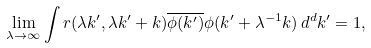<formula> <loc_0><loc_0><loc_500><loc_500>\lim _ { \lambda \to \infty } \int r ( \lambda k ^ { \prime } , \lambda k ^ { \prime } + k ) \overline { \phi ( k ^ { \prime } ) } \phi ( k ^ { \prime } + \lambda ^ { - 1 } k ) \, d ^ { d } k ^ { \prime } = 1 ,</formula> 